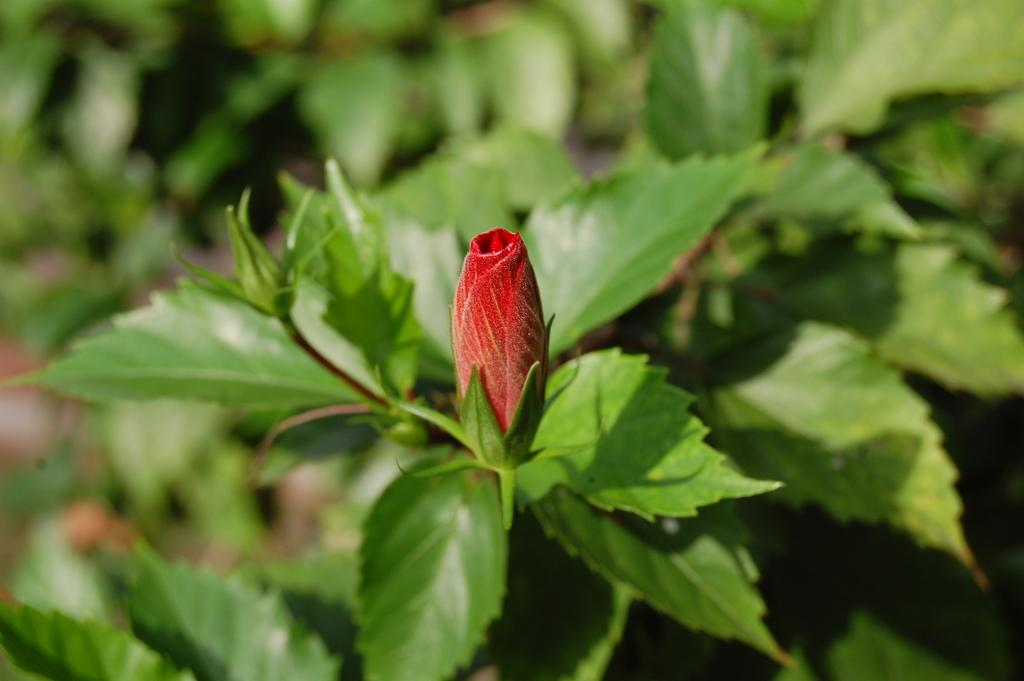What type of flower is in the image? There is a red flower in the image. Where is the red flower located? The red flower is on a plant. How many letters does the red flower spell out in the image? The red flower does not spell out any letters in the image, as it is a natural object and not a form of communication. 